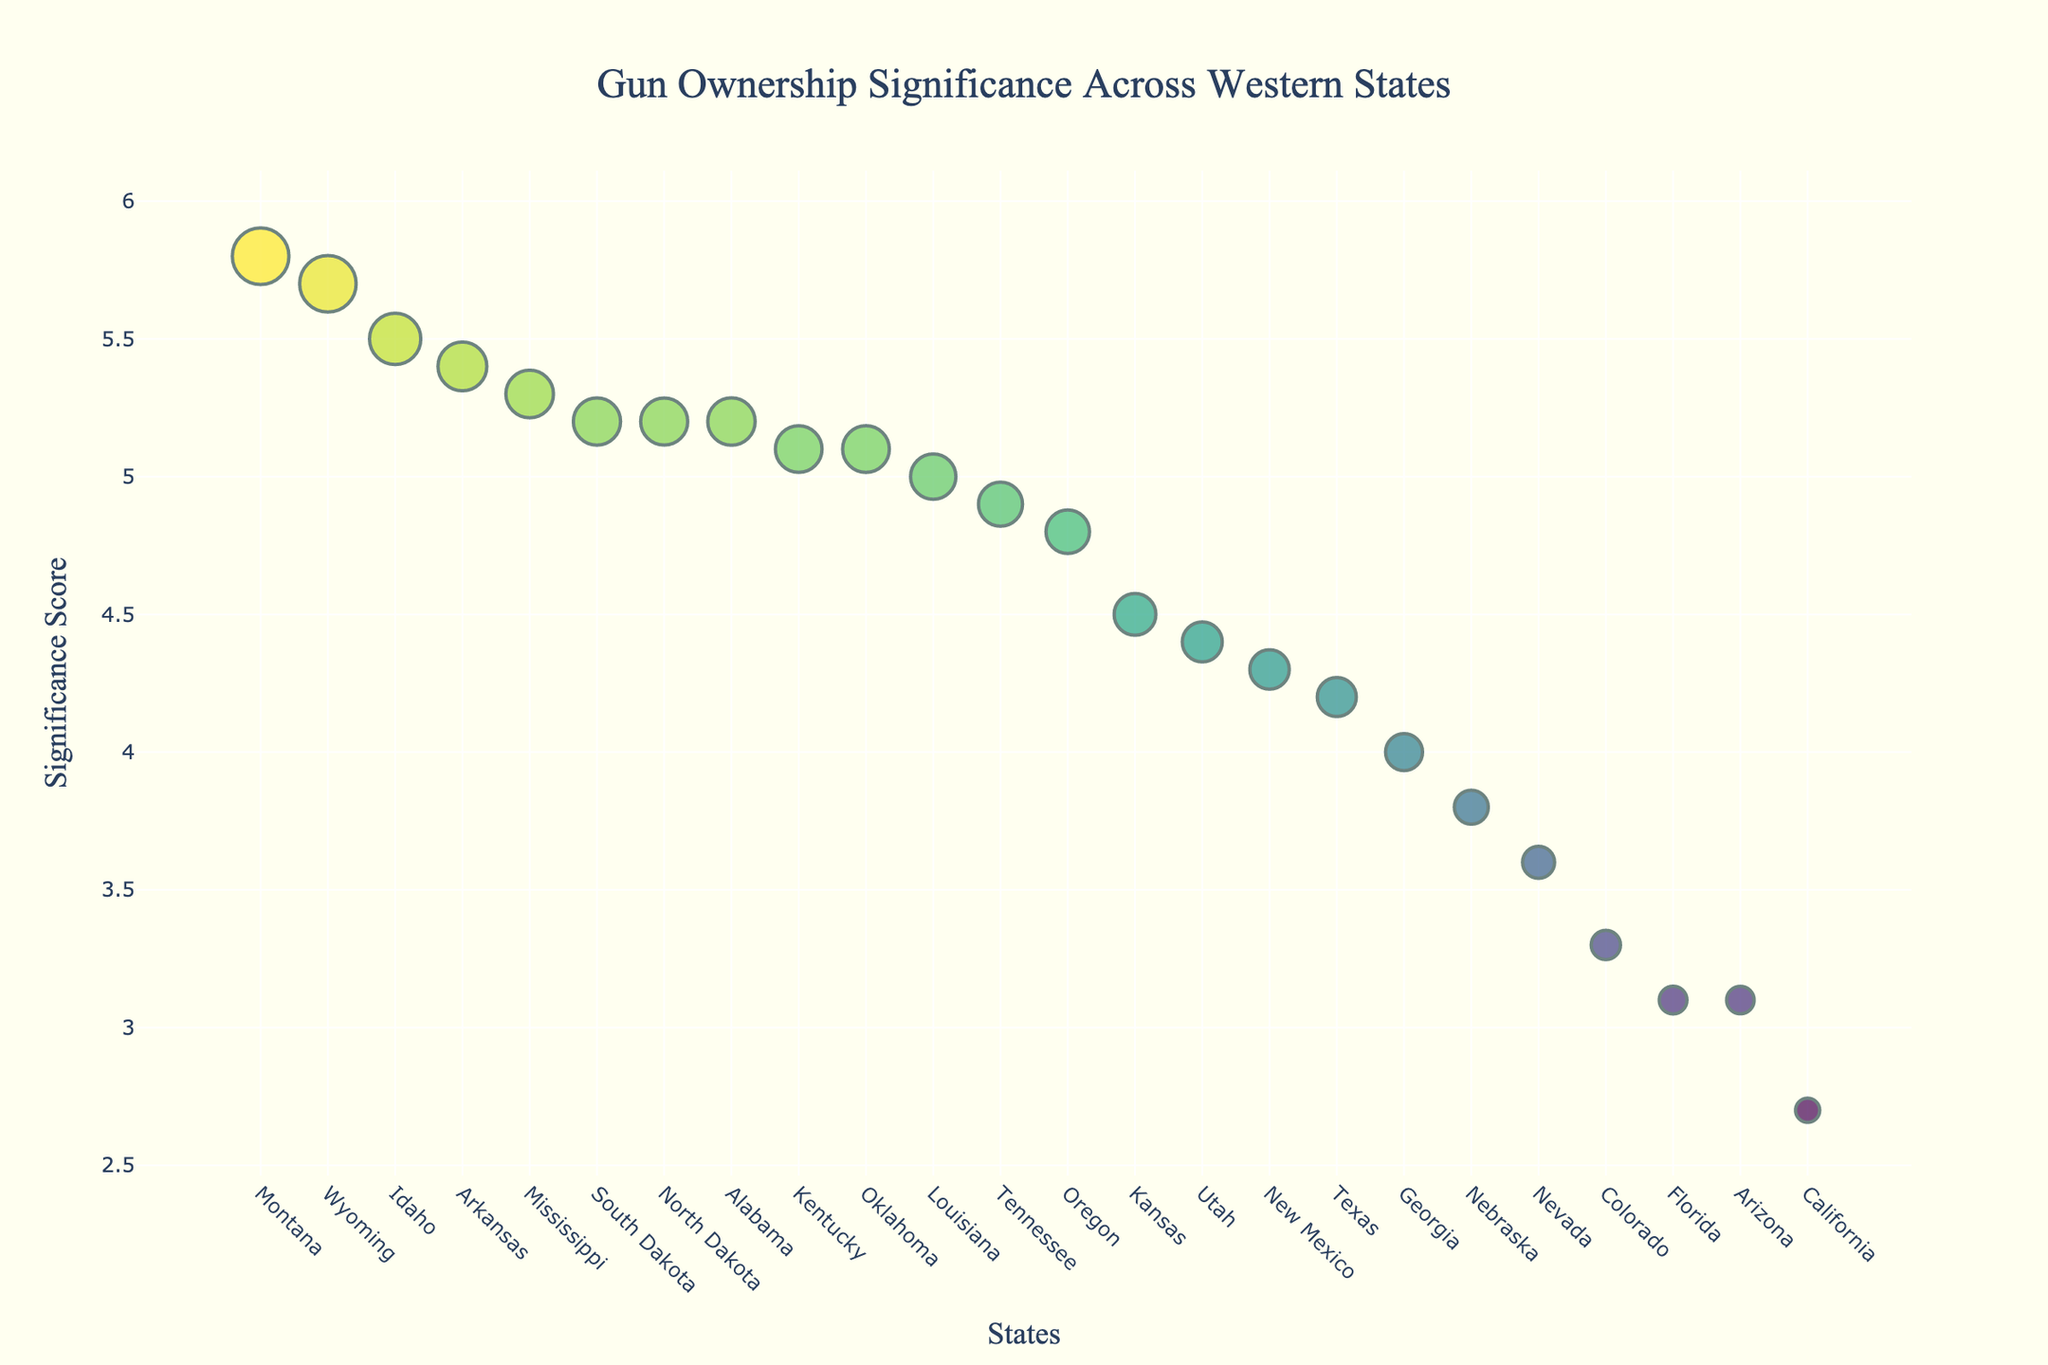Which state has the highest gun ownership significance score? The significance score is represented on the y-axis. The state with the highest point on this axis is Montana.
Answer: Montana Which state has the lowest gun ownership rate among the ones shown? The gun ownership rate is indicated by the size of the markers. The smallest marker belongs to California, which has a gun ownership rate of 28.3%.
Answer: California How many states have a significance score greater than 5? By observing the y-axis and the markers above the score of 5, we can count seven states: Montana, Wyoming, South Dakota, North Dakota, Idaho, Alabama, and Mississippi.
Answer: 7 Which state has the largest marker, and what is its gun ownership rate? The largest marker indicates the highest gun ownership rate. By observing the marker sizes, Montana stands out with a rate of 66.3%.
Answer: Montana, 66.3% What's the difference in significance score between Texas and Idaho? Texas has a significance score of 4.2, and Idaho has a score of 5.5. Subtracting these gives 5.5 - 4.2 = 1.3.
Answer: 1.3 Are there more states below the average significance score or above it? To determine this, we compute the average significance score, which involves summing all scores and dividing by the number of states. The average score is (4.2 + 5.8 + 5.7 + 4.3 + 3.1 + 3.3 + 3.6 + 5.1 + 4.5 + 3.8 + 5.2 + 5.2 + 5.5 + 4.4 + 4.8 + 2.7 + 5.1 + 4.9 + 4.0 + 3.1 + 5.2 + 5.3 + 5.0 + 5.4) / 24 ≈ 4.57. Counting the states, there are 11 states with scores above 4.57 and 13 states below it.
Answer: Below What is the median gun ownership rate for the states listed? To find the median, we list all the gun ownership rates in ascending order and find the middle value(s). The rates are: 28.3, 32.3, 32.5, 34.3, 37.5, 39.8, 43.3, 45.7, 46.2, 46.8, 48.9, 51.0, 51.6, 53.1, 54.6, 54.7, 55.1, 55.3, 55.5, 55.8, 57.2, 60.1, 66.2, 66.3. The middle two are 48.9 and 51.0, so the median is (48.9 + 51.0) / 2 = 49.95.
Answer: 49.95 Which state has a higher significance score: Arizona or Utah? By looking at the points for Arizona and Utah, we find Arizona has a score of 3.1 and Utah has 4.4. Thus, Utah has a higher score.
Answer: Utah What is the total gun ownership rate sum for Oklahoma and Kansas? Adding the gun ownership rates of Oklahoma (54.7%) and Kansas (48.9%) gives 54.7 + 48.9 = 103.6.
Answer: 103.6 Which state, commonly associated with Westerns, has a lower gun ownership rate: Texas or New Mexico? Comparing Texas with a rate of 45.7% and New Mexico with 46.2%, Texas has the lower gun ownership rate.
Answer: Texas 